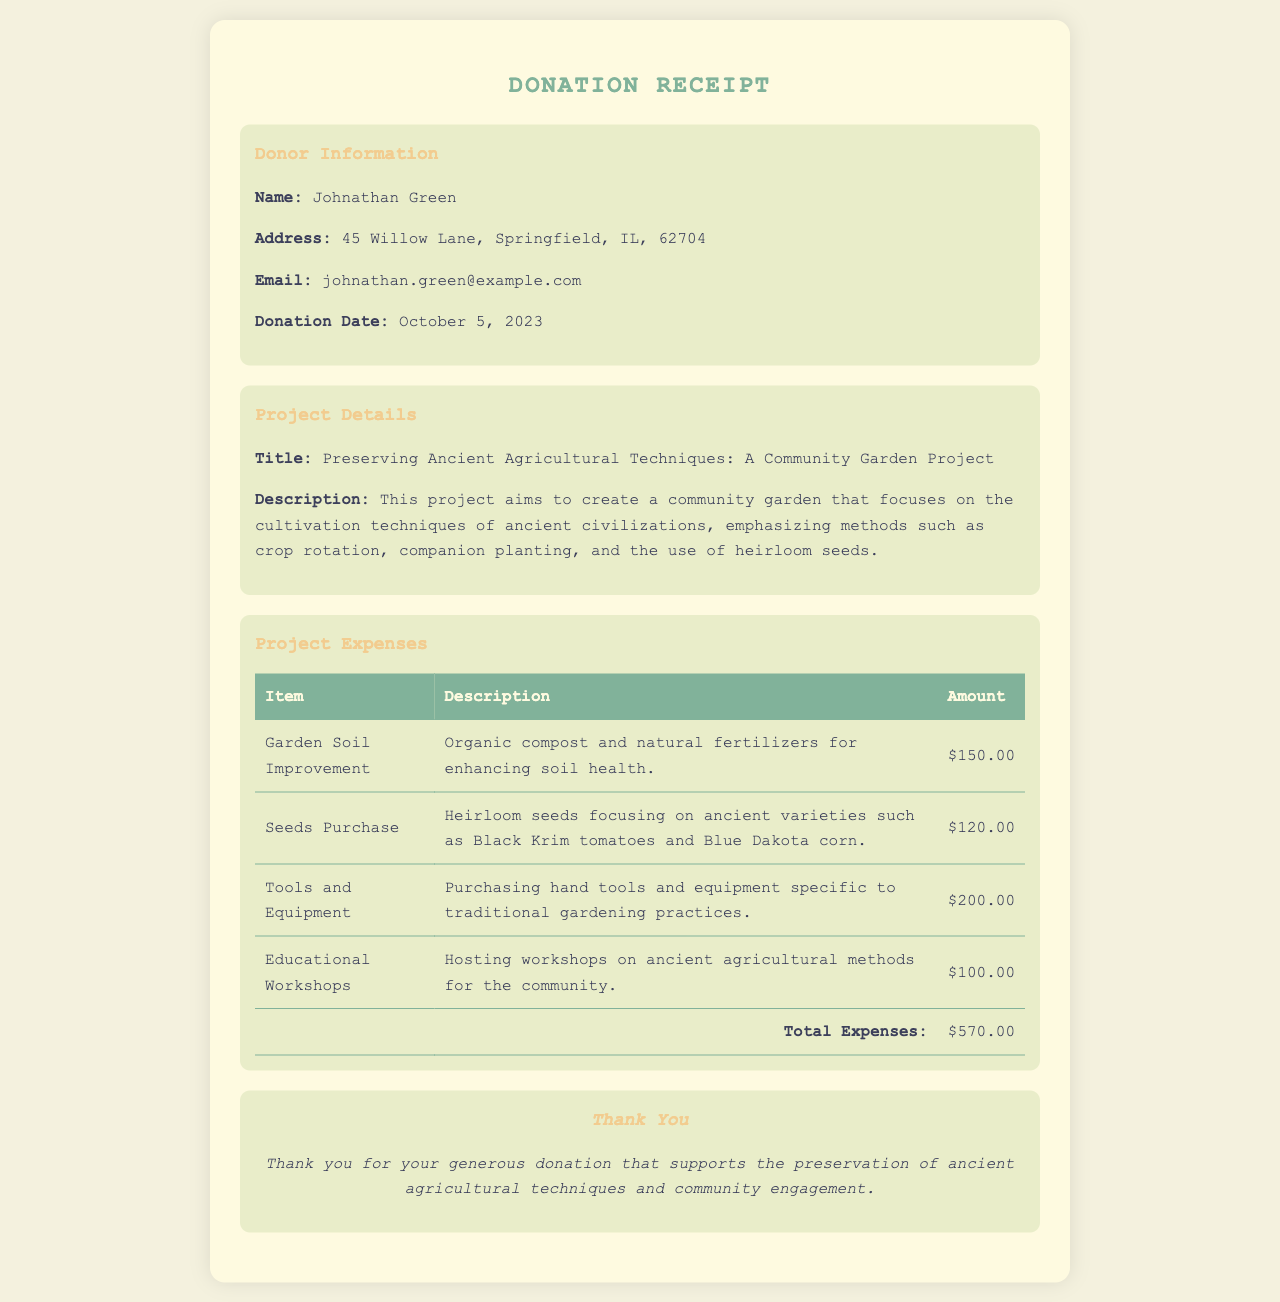What is the donor's name? The donor's name is found in the donor information section of the receipt.
Answer: Johnathan Green What is the donation date? The donation date is specified in the donor information section.
Answer: October 5, 2023 What is the total amount of project expenses? The total expenses are calculated from the items listed in the project expenses section.
Answer: $570.00 What is the address of the donor? The donor's address is stated in the donor information section.
Answer: 45 Willow Lane, Springfield, IL, 62704 What is the title of the project? The title of the project is mentioned in the project details section.
Answer: Preserving Ancient Agricultural Techniques: A Community Garden Project What type of seeds are being focused on for the project? The type of seeds is mentioned in the description of the seeds purchase in the expenses section.
Answer: Heirloom seeds How many items are listed in the project expenses? The number of items can be counted in the expenses section of the document.
Answer: 4 What is the purpose of the educational workshops? The purpose is provided in the description of the educational workshops within the expenses section.
Answer: Hosting workshops on ancient agricultural methods What is the primary focus of the community garden project? The focus is elaborated in the project description section.
Answer: Cultivation techniques of ancient civilizations 